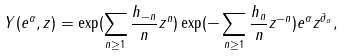Convert formula to latex. <formula><loc_0><loc_0><loc_500><loc_500>Y ( e ^ { \alpha } , z ) = \exp ( \sum _ { n \geq 1 } \frac { h _ { - n } } { n } z ^ { n } ) \exp ( - \sum _ { n \geq 1 } \frac { h _ { n } } { n } z ^ { - n } ) e ^ { \alpha } z ^ { \partial _ { \alpha } } ,</formula> 